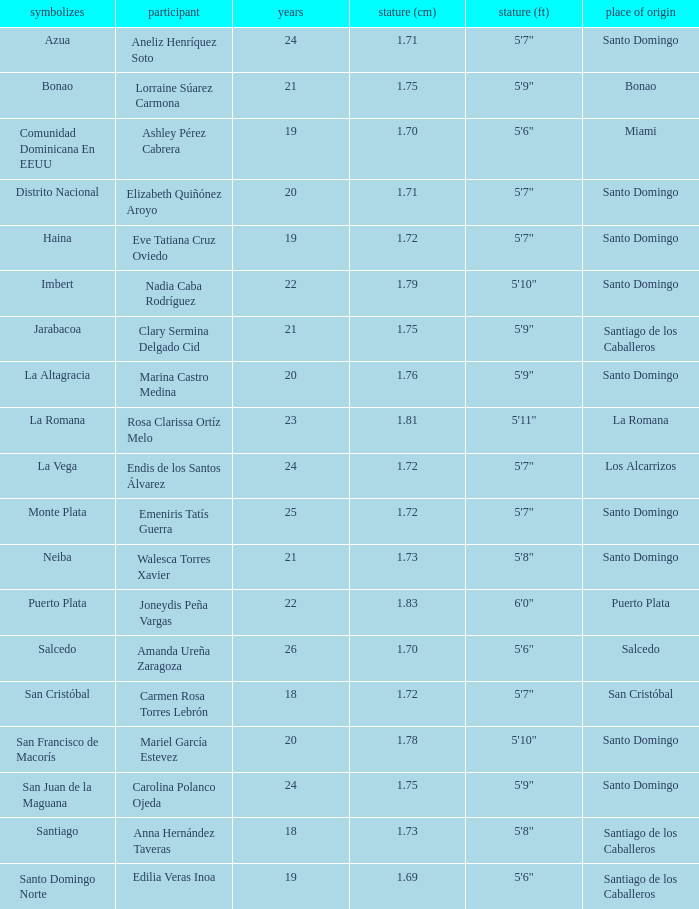Name the represents for 1.76 cm La Altagracia. 